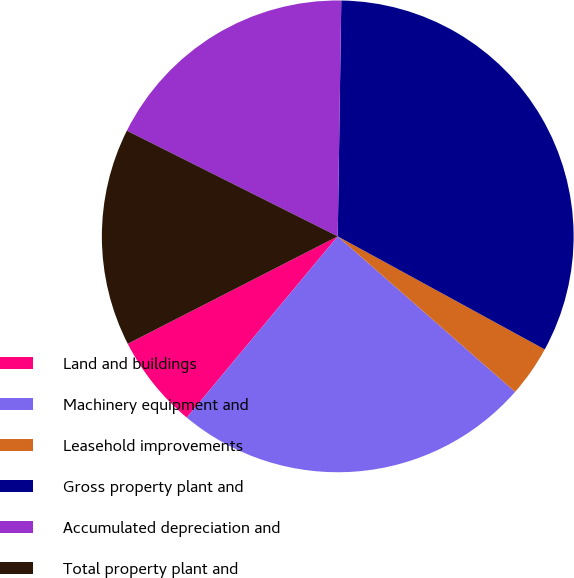Convert chart. <chart><loc_0><loc_0><loc_500><loc_500><pie_chart><fcel>Land and buildings<fcel>Machinery equipment and<fcel>Leasehold improvements<fcel>Gross property plant and<fcel>Accumulated depreciation and<fcel>Total property plant and<nl><fcel>6.42%<fcel>24.6%<fcel>3.5%<fcel>32.72%<fcel>17.85%<fcel>14.92%<nl></chart> 